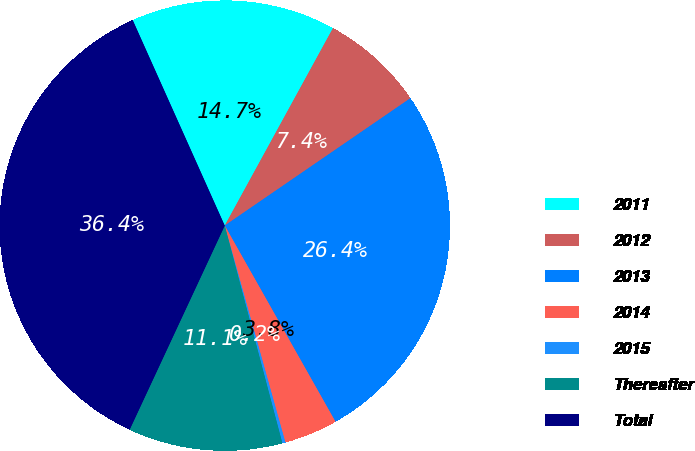Convert chart to OTSL. <chart><loc_0><loc_0><loc_500><loc_500><pie_chart><fcel>2011<fcel>2012<fcel>2013<fcel>2014<fcel>2015<fcel>Thereafter<fcel>Total<nl><fcel>14.68%<fcel>7.45%<fcel>26.39%<fcel>3.84%<fcel>0.22%<fcel>11.06%<fcel>36.36%<nl></chart> 